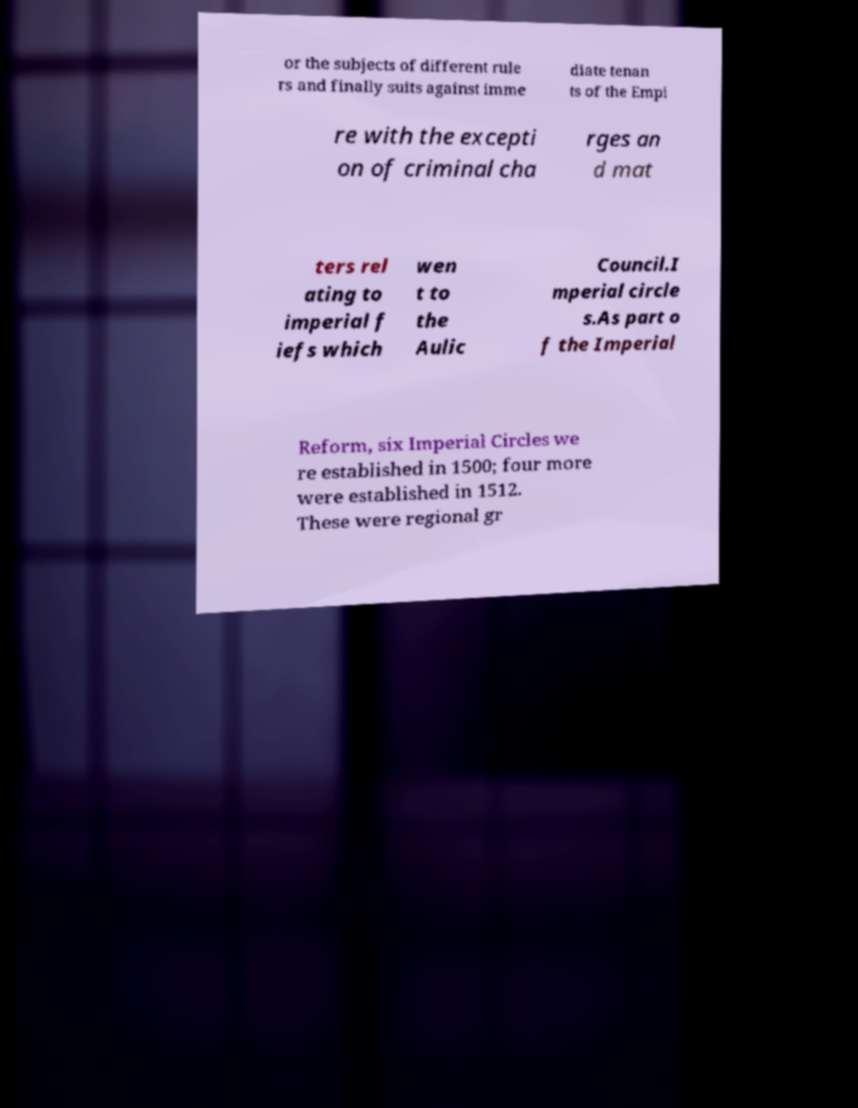Please identify and transcribe the text found in this image. or the subjects of different rule rs and finally suits against imme diate tenan ts of the Empi re with the excepti on of criminal cha rges an d mat ters rel ating to imperial f iefs which wen t to the Aulic Council.I mperial circle s.As part o f the Imperial Reform, six Imperial Circles we re established in 1500; four more were established in 1512. These were regional gr 